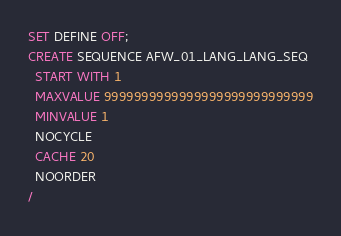Convert code to text. <code><loc_0><loc_0><loc_500><loc_500><_SQL_>SET DEFINE OFF;
CREATE SEQUENCE AFW_01_LANG_LANG_SEQ
  START WITH 1
  MAXVALUE 9999999999999999999999999999
  MINVALUE 1
  NOCYCLE
  CACHE 20
  NOORDER
/
</code> 